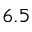<formula> <loc_0><loc_0><loc_500><loc_500>6 . 5</formula> 